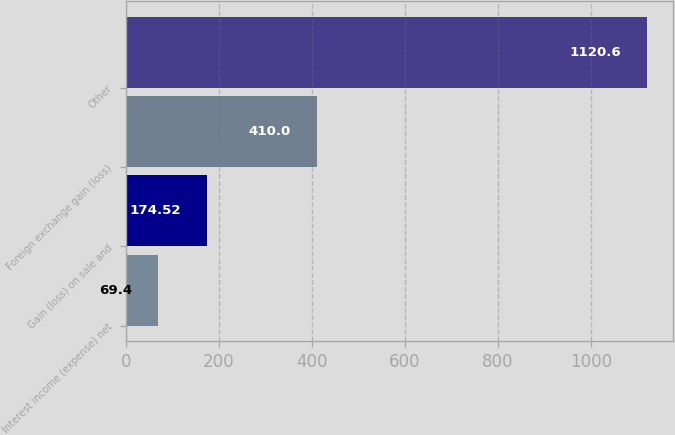Convert chart. <chart><loc_0><loc_0><loc_500><loc_500><bar_chart><fcel>Interest income (expense) net<fcel>Gain (loss) on sale and<fcel>Foreign exchange gain (loss)<fcel>Other<nl><fcel>69.4<fcel>174.52<fcel>410<fcel>1120.6<nl></chart> 